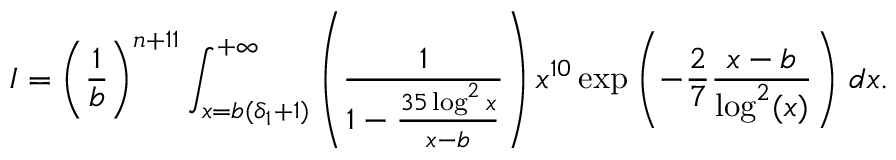Convert formula to latex. <formula><loc_0><loc_0><loc_500><loc_500>I = \left ( \frac { 1 } { b } \right ) ^ { n + 1 1 } \int _ { x = b ( \delta _ { 1 } + 1 ) } ^ { + \infty } \left ( \frac { 1 } { 1 - \frac { 3 5 \log ^ { 2 } x } { x - b } } \right ) x ^ { 1 0 } \exp \left ( - \frac { 2 } { 7 } \frac { x - b } { \log ^ { 2 } ( x ) } \right ) \, d x .</formula> 